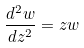<formula> <loc_0><loc_0><loc_500><loc_500>\frac { d ^ { 2 } w } { d z ^ { 2 } } = z w</formula> 